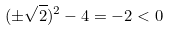Convert formula to latex. <formula><loc_0><loc_0><loc_500><loc_500>( \pm \sqrt { 2 } ) ^ { 2 } - 4 = - 2 < 0</formula> 